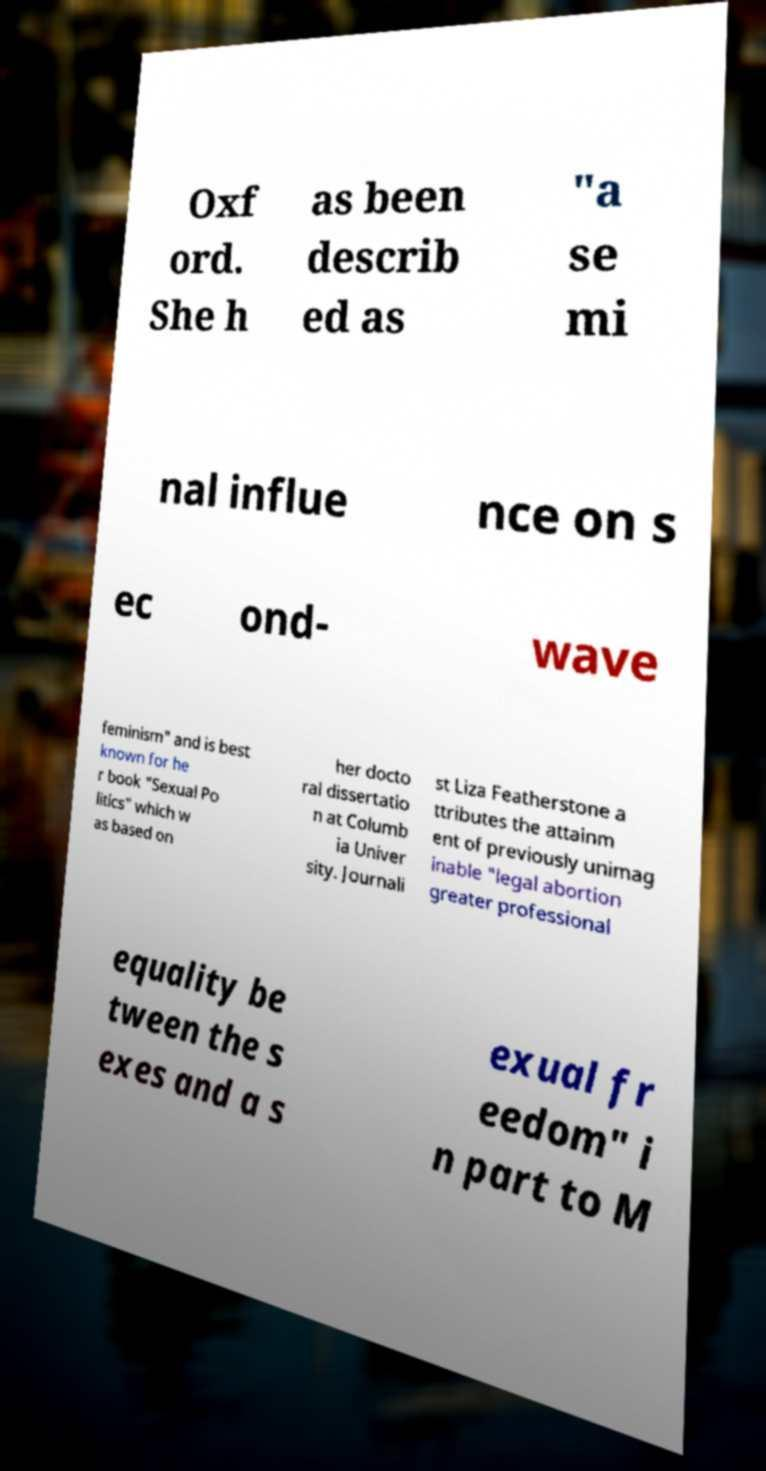I need the written content from this picture converted into text. Can you do that? Oxf ord. She h as been describ ed as "a se mi nal influe nce on s ec ond- wave feminism" and is best known for he r book "Sexual Po litics" which w as based on her docto ral dissertatio n at Columb ia Univer sity. Journali st Liza Featherstone a ttributes the attainm ent of previously unimag inable "legal abortion greater professional equality be tween the s exes and a s exual fr eedom" i n part to M 